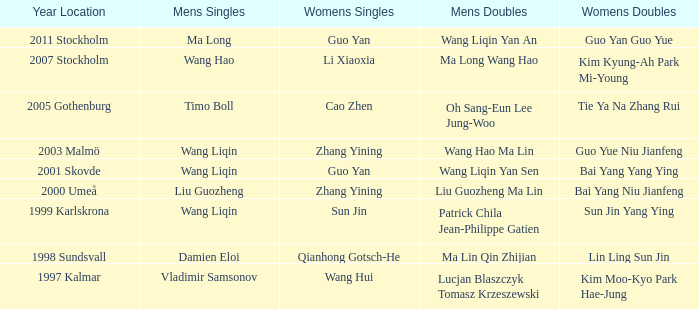How many instances has ma long secured the men's singles championship? 1.0. 